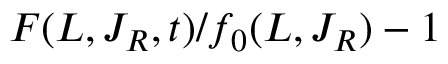Convert formula to latex. <formula><loc_0><loc_0><loc_500><loc_500>F ( L , J _ { R } , t ) / f _ { 0 } ( L , J _ { R } ) - 1</formula> 